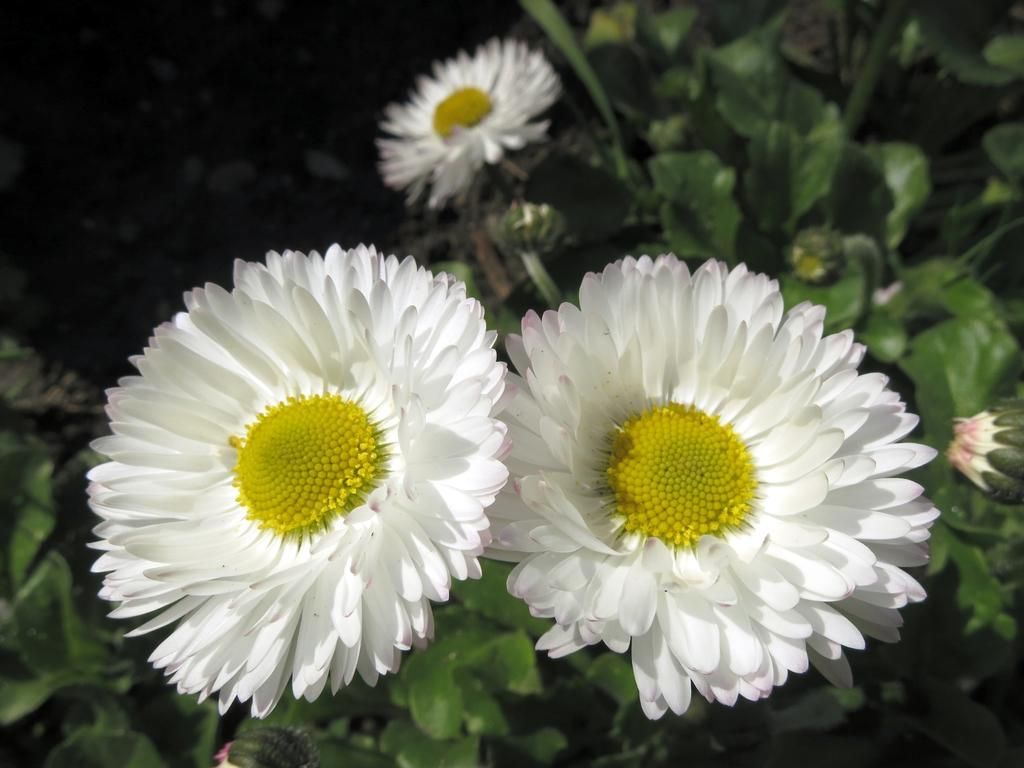What color are the flowers on the plants in the image? The flowers on the plants are white. What stage of growth are the plants in? The plants have buds, indicating they are in the early stages of growth. How would you describe the background of the image? The background appears dark in the image. What type of downtown area can be seen in the image? There is no downtown area present in the image; it features plants with white flowers and buds against a dark background. 